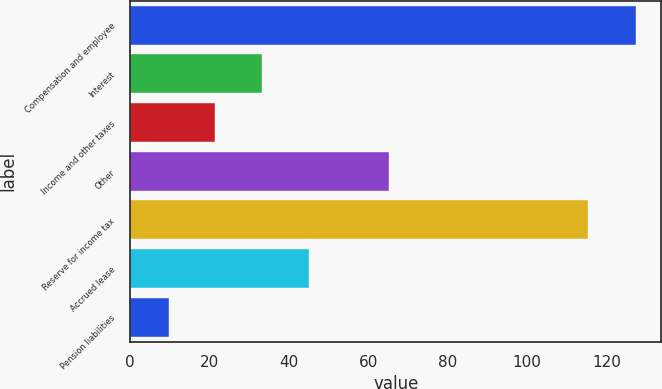<chart> <loc_0><loc_0><loc_500><loc_500><bar_chart><fcel>Compensation and employee<fcel>Interest<fcel>Income and other taxes<fcel>Other<fcel>Reserve for income tax<fcel>Accrued lease<fcel>Pension liabilities<nl><fcel>127.5<fcel>33.26<fcel>21.48<fcel>65.2<fcel>115.4<fcel>45.04<fcel>9.7<nl></chart> 